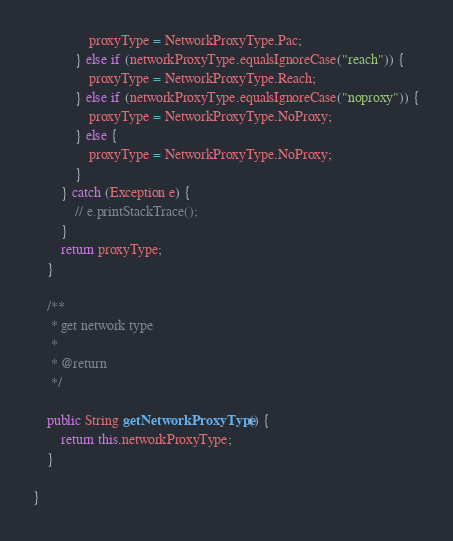<code> <loc_0><loc_0><loc_500><loc_500><_Java_>                proxyType = NetworkProxyType.Pac;
            } else if (networkProxyType.equalsIgnoreCase("reach")) {
                proxyType = NetworkProxyType.Reach;
            } else if (networkProxyType.equalsIgnoreCase("noproxy")) {
                proxyType = NetworkProxyType.NoProxy;
            } else {
                proxyType = NetworkProxyType.NoProxy;
            }
        } catch (Exception e) {
            // e.printStackTrace();
        }
        return proxyType;
    }

    /**
     * get network type
     *
     * @return
     */

    public String getNetworkProxyType() {
        return this.networkProxyType;
    }

}
</code> 